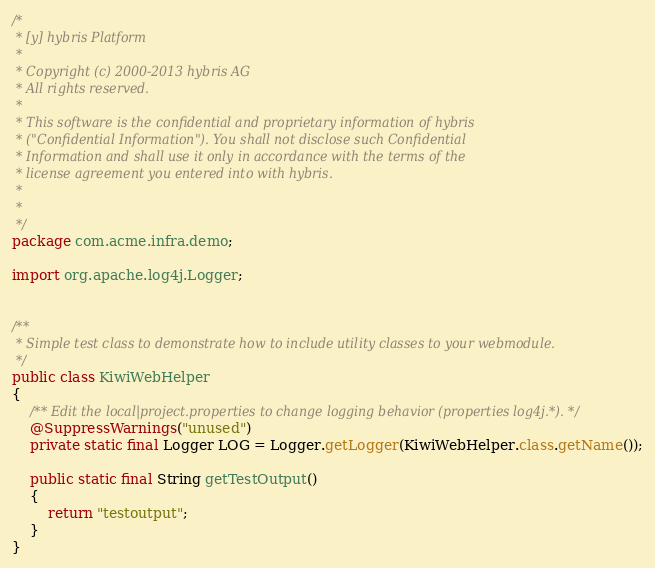<code> <loc_0><loc_0><loc_500><loc_500><_Java_>/*
 * [y] hybris Platform
 *
 * Copyright (c) 2000-2013 hybris AG
 * All rights reserved.
 *
 * This software is the confidential and proprietary information of hybris
 * ("Confidential Information"). You shall not disclose such Confidential
 * Information and shall use it only in accordance with the terms of the
 * license agreement you entered into with hybris.
 * 
 *  
 */
package com.acme.infra.demo;

import org.apache.log4j.Logger;


/**
 * Simple test class to demonstrate how to include utility classes to your webmodule.
 */
public class KiwiWebHelper
{
	/** Edit the local|project.properties to change logging behavior (properties log4j.*). */
	@SuppressWarnings("unused")
	private static final Logger LOG = Logger.getLogger(KiwiWebHelper.class.getName());

	public static final String getTestOutput()
	{
		return "testoutput";
	}
}
</code> 